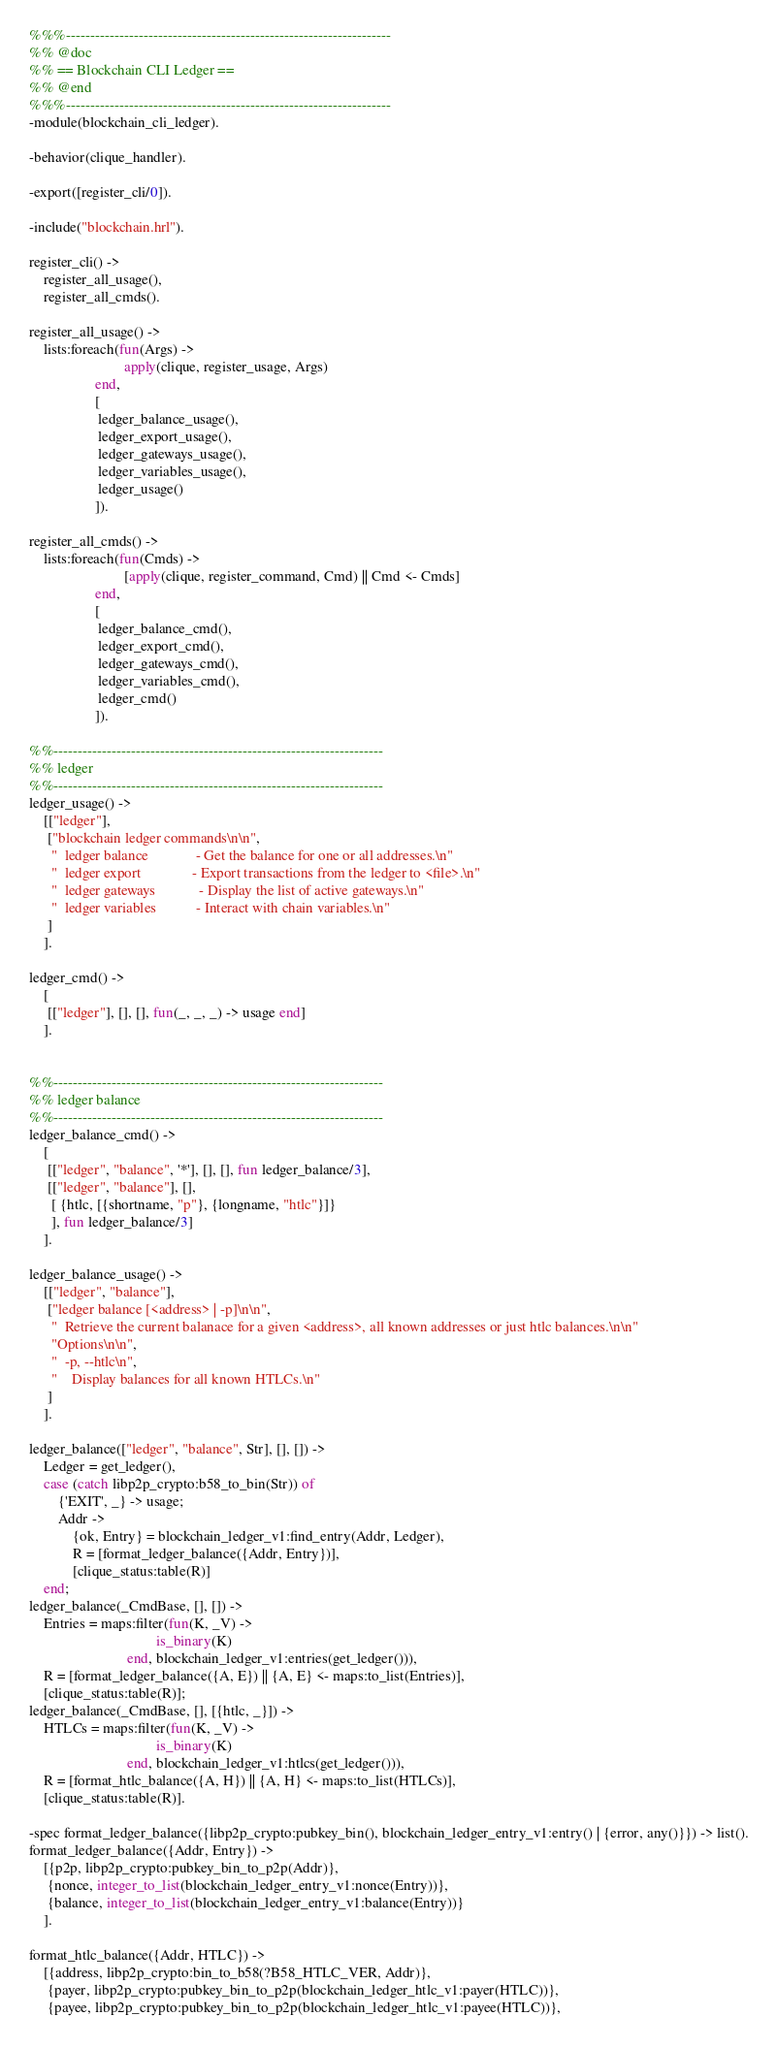Convert code to text. <code><loc_0><loc_0><loc_500><loc_500><_Erlang_>%%%-------------------------------------------------------------------
%% @doc
%% == Blockchain CLI Ledger ==
%% @end
%%%-------------------------------------------------------------------
-module(blockchain_cli_ledger).

-behavior(clique_handler).

-export([register_cli/0]).

-include("blockchain.hrl").

register_cli() ->
    register_all_usage(),
    register_all_cmds().

register_all_usage() ->
    lists:foreach(fun(Args) ->
                          apply(clique, register_usage, Args)
                  end,
                  [
                   ledger_balance_usage(),
                   ledger_export_usage(),
                   ledger_gateways_usage(),
                   ledger_variables_usage(),
                   ledger_usage()
                  ]).

register_all_cmds() ->
    lists:foreach(fun(Cmds) ->
                          [apply(clique, register_command, Cmd) || Cmd <- Cmds]
                  end,
                  [
                   ledger_balance_cmd(),
                   ledger_export_cmd(),
                   ledger_gateways_cmd(),
                   ledger_variables_cmd(),
                   ledger_cmd()
                  ]).

%%--------------------------------------------------------------------
%% ledger
%%--------------------------------------------------------------------
ledger_usage() ->
    [["ledger"],
     ["blockchain ledger commands\n\n",
      "  ledger balance             - Get the balance for one or all addresses.\n"
      "  ledger export              - Export transactions from the ledger to <file>.\n"
      "  ledger gateways            - Display the list of active gateways.\n"
      "  ledger variables           - Interact with chain variables.\n"
     ]
    ].

ledger_cmd() ->
    [
     [["ledger"], [], [], fun(_, _, _) -> usage end]
    ].


%%--------------------------------------------------------------------
%% ledger balance
%%--------------------------------------------------------------------
ledger_balance_cmd() ->
    [
     [["ledger", "balance", '*'], [], [], fun ledger_balance/3],
     [["ledger", "balance"], [],
      [ {htlc, [{shortname, "p"}, {longname, "htlc"}]}
      ], fun ledger_balance/3]
    ].

ledger_balance_usage() ->
    [["ledger", "balance"],
     ["ledger balance [<address> | -p]\n\n",
      "  Retrieve the current balanace for a given <address>, all known addresses or just htlc balances.\n\n"
      "Options\n\n",
      "  -p, --htlc\n",
      "    Display balances for all known HTLCs.\n"
     ]
    ].

ledger_balance(["ledger", "balance", Str], [], []) ->
    Ledger = get_ledger(),
    case (catch libp2p_crypto:b58_to_bin(Str)) of
        {'EXIT', _} -> usage;
        Addr ->
            {ok, Entry} = blockchain_ledger_v1:find_entry(Addr, Ledger),
            R = [format_ledger_balance({Addr, Entry})],
            [clique_status:table(R)]
    end;
ledger_balance(_CmdBase, [], []) ->
    Entries = maps:filter(fun(K, _V) ->
                                   is_binary(K)
                           end, blockchain_ledger_v1:entries(get_ledger())),
    R = [format_ledger_balance({A, E}) || {A, E} <- maps:to_list(Entries)],
    [clique_status:table(R)];
ledger_balance(_CmdBase, [], [{htlc, _}]) ->
    HTLCs = maps:filter(fun(K, _V) ->
                                   is_binary(K)
                           end, blockchain_ledger_v1:htlcs(get_ledger())),
    R = [format_htlc_balance({A, H}) || {A, H} <- maps:to_list(HTLCs)],
    [clique_status:table(R)].

-spec format_ledger_balance({libp2p_crypto:pubkey_bin(), blockchain_ledger_entry_v1:entry() | {error, any()}}) -> list().
format_ledger_balance({Addr, Entry}) ->
    [{p2p, libp2p_crypto:pubkey_bin_to_p2p(Addr)},
     {nonce, integer_to_list(blockchain_ledger_entry_v1:nonce(Entry))},
     {balance, integer_to_list(blockchain_ledger_entry_v1:balance(Entry))}
    ].

format_htlc_balance({Addr, HTLC}) ->
    [{address, libp2p_crypto:bin_to_b58(?B58_HTLC_VER, Addr)},
     {payer, libp2p_crypto:pubkey_bin_to_p2p(blockchain_ledger_htlc_v1:payer(HTLC))},
     {payee, libp2p_crypto:pubkey_bin_to_p2p(blockchain_ledger_htlc_v1:payee(HTLC))},</code> 